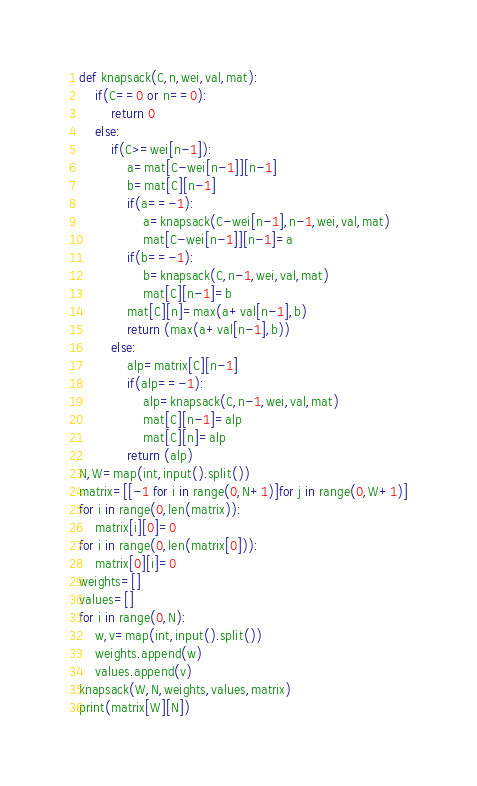<code> <loc_0><loc_0><loc_500><loc_500><_Python_>def knapsack(C,n,wei,val,mat):
    if(C==0 or n==0):
        return 0
    else:
        if(C>=wei[n-1]):
            a=mat[C-wei[n-1]][n-1]
            b=mat[C][n-1]
            if(a==-1):
                a=knapsack(C-wei[n-1],n-1,wei,val,mat)
                mat[C-wei[n-1]][n-1]=a
            if(b==-1):
                b=knapsack(C,n-1,wei,val,mat)
                mat[C][n-1]=b
            mat[C][n]=max(a+val[n-1],b)
            return (max(a+val[n-1],b))
        else:
            alp=matrix[C][n-1]
            if(alp==-1):
                alp=knapsack(C,n-1,wei,val,mat)
                mat[C][n-1]=alp
                mat[C][n]=alp
            return (alp)
N,W=map(int,input().split())
matrix=[[-1 for i in range(0,N+1)]for j in range(0,W+1)]
for i in range(0,len(matrix)):
    matrix[i][0]=0
for i in range(0,len(matrix[0])):
    matrix[0][i]=0
weights=[]
values=[]
for i in range(0,N):
    w,v=map(int,input().split())
    weights.append(w)
    values.append(v)
knapsack(W,N,weights,values,matrix)
print(matrix[W][N])</code> 